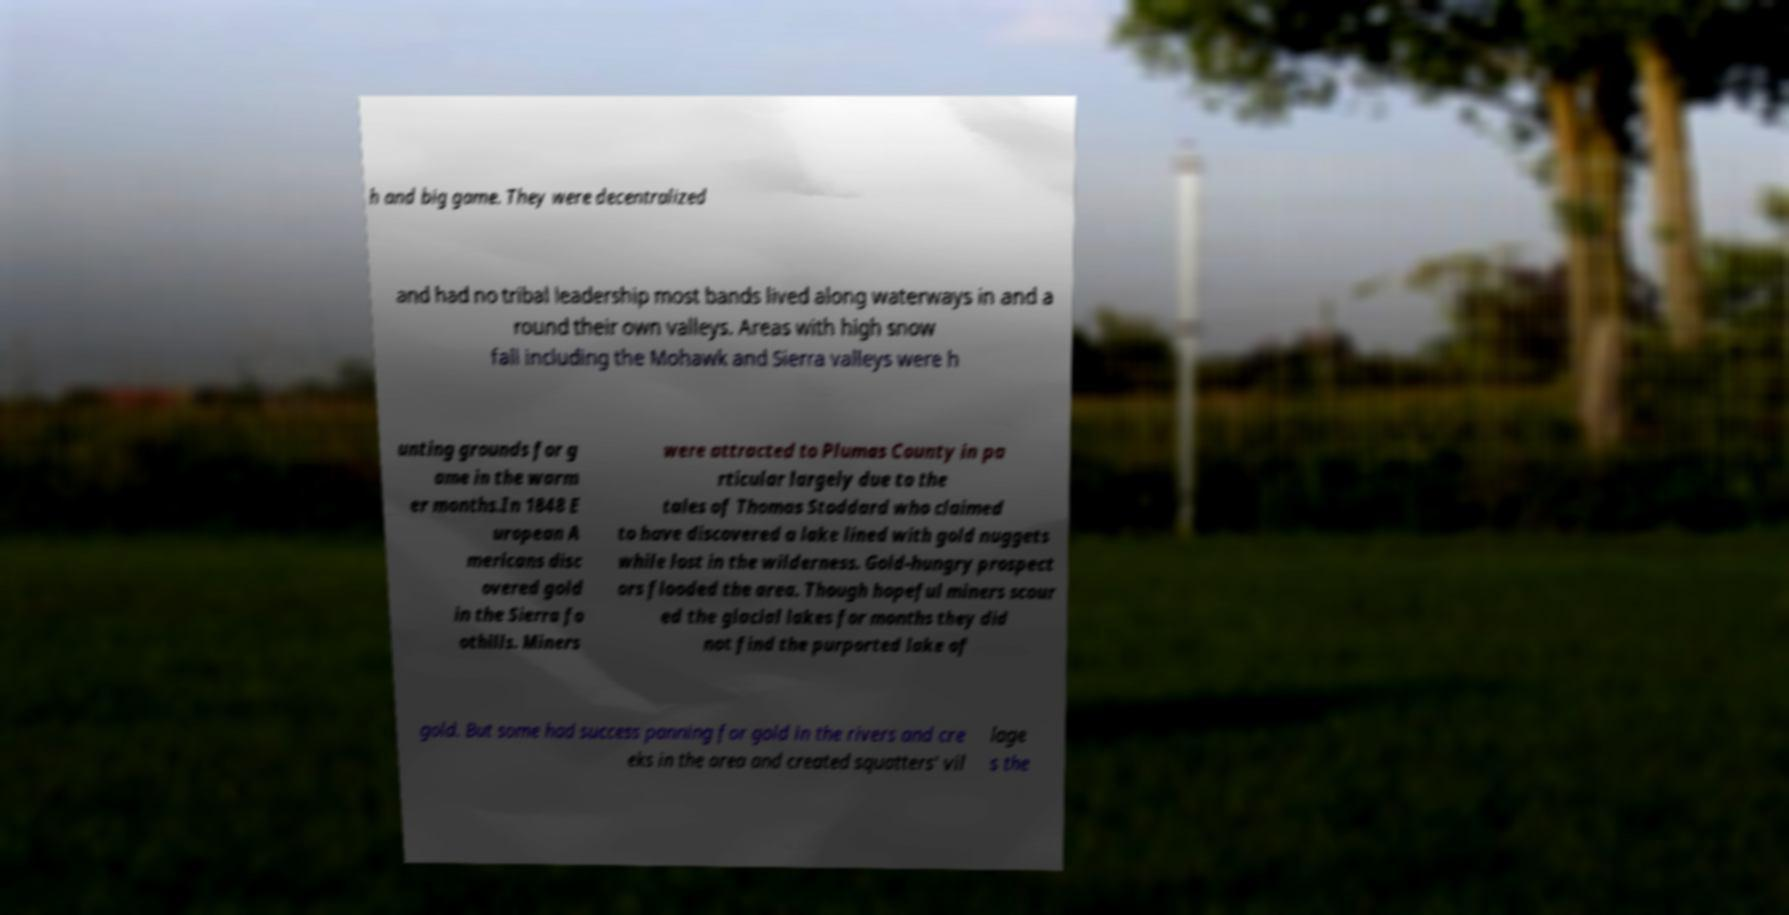Please read and relay the text visible in this image. What does it say? h and big game. They were decentralized and had no tribal leadership most bands lived along waterways in and a round their own valleys. Areas with high snow fall including the Mohawk and Sierra valleys were h unting grounds for g ame in the warm er months.In 1848 E uropean A mericans disc overed gold in the Sierra fo othills. Miners were attracted to Plumas County in pa rticular largely due to the tales of Thomas Stoddard who claimed to have discovered a lake lined with gold nuggets while lost in the wilderness. Gold-hungry prospect ors flooded the area. Though hopeful miners scour ed the glacial lakes for months they did not find the purported lake of gold. But some had success panning for gold in the rivers and cre eks in the area and created squatters' vil lage s the 